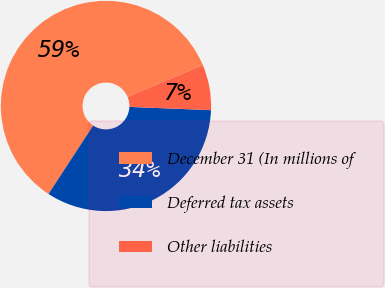Convert chart to OTSL. <chart><loc_0><loc_0><loc_500><loc_500><pie_chart><fcel>December 31 (In millions of<fcel>Deferred tax assets<fcel>Other liabilities<nl><fcel>59.44%<fcel>33.57%<fcel>6.99%<nl></chart> 